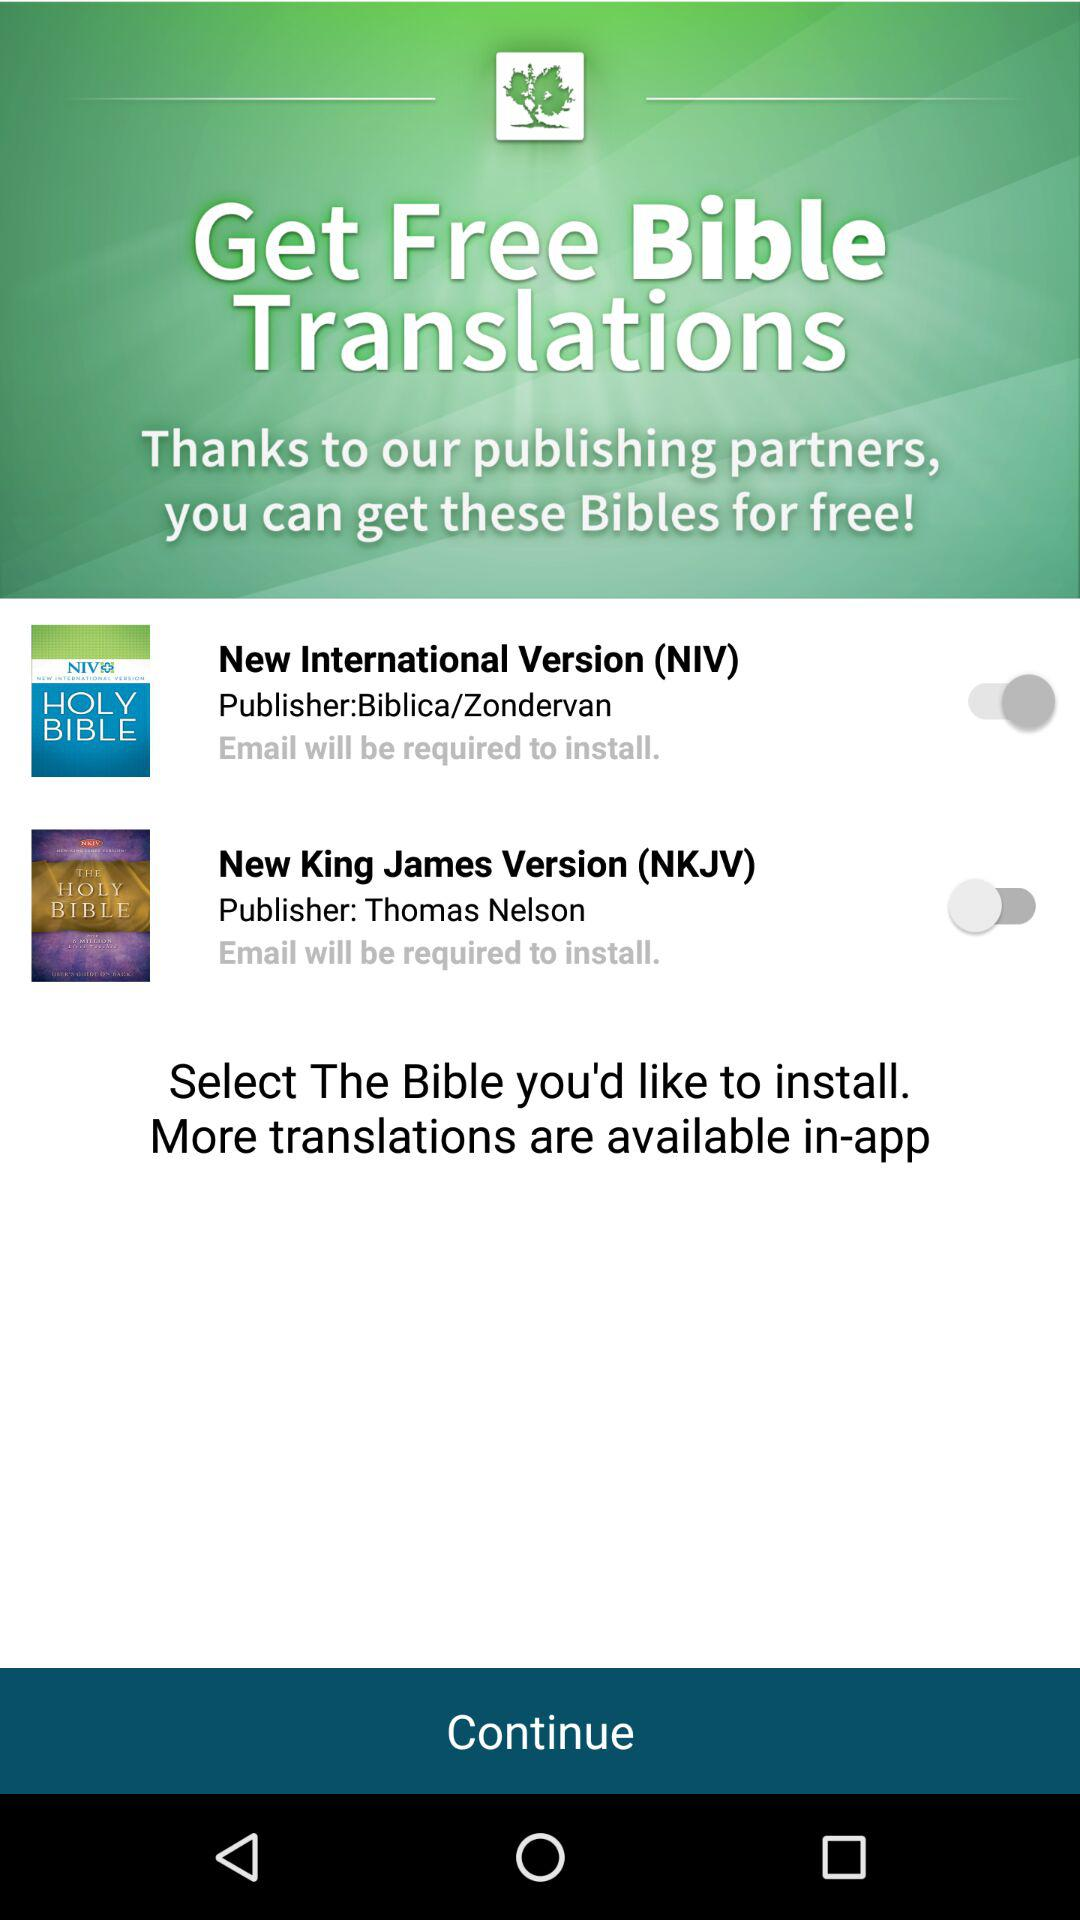How many Bible translations are available for free?
Answer the question using a single word or phrase. 2 